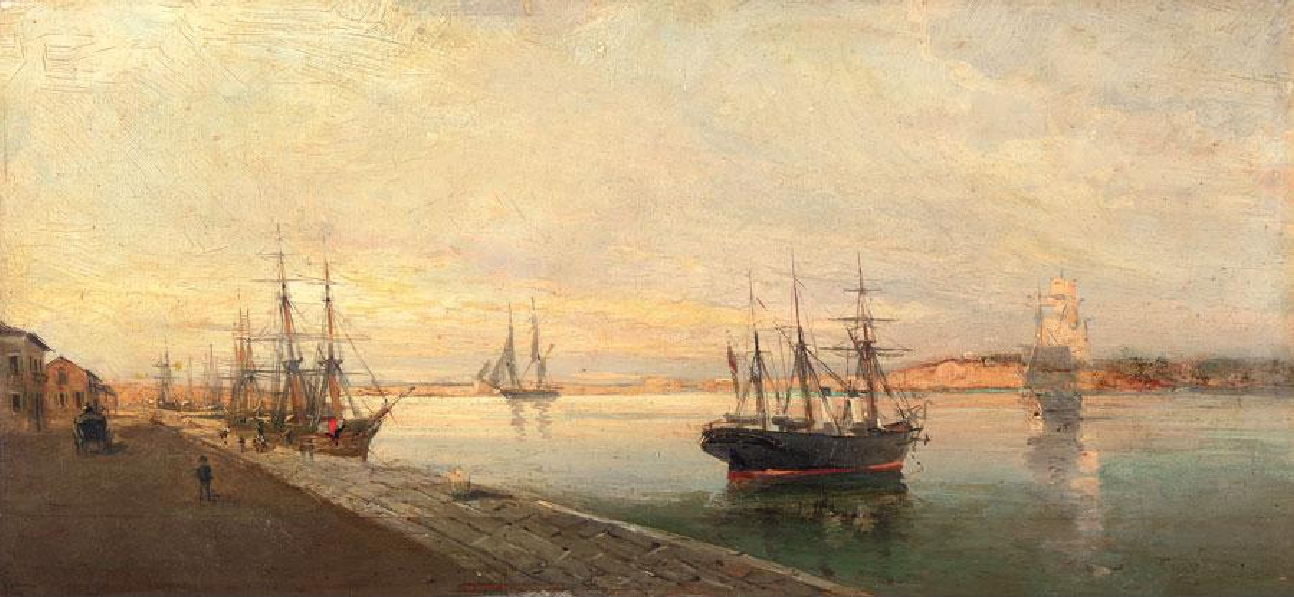What atmosphere does the painting depict, and how does the artist achieve it? The painting conveys a tranquil and reflective atmosphere, one that invites the viewer to ponder the quiet moments of life by the sea. The artist achieves this through the subtle interplay of light and shadow, painting the sky with gentle, warm colors that suggest the serenity of twilight hours. The brushstrokes are soft and suggest movement, while not overpowering the viewer with detail, allowing the scene to feel alive yet composed. Furthermore, the positioning of the ships at rest, coupled with the mirror-like water and sparse activity on the docks, adds to the overall feeling of calm and stillness. 